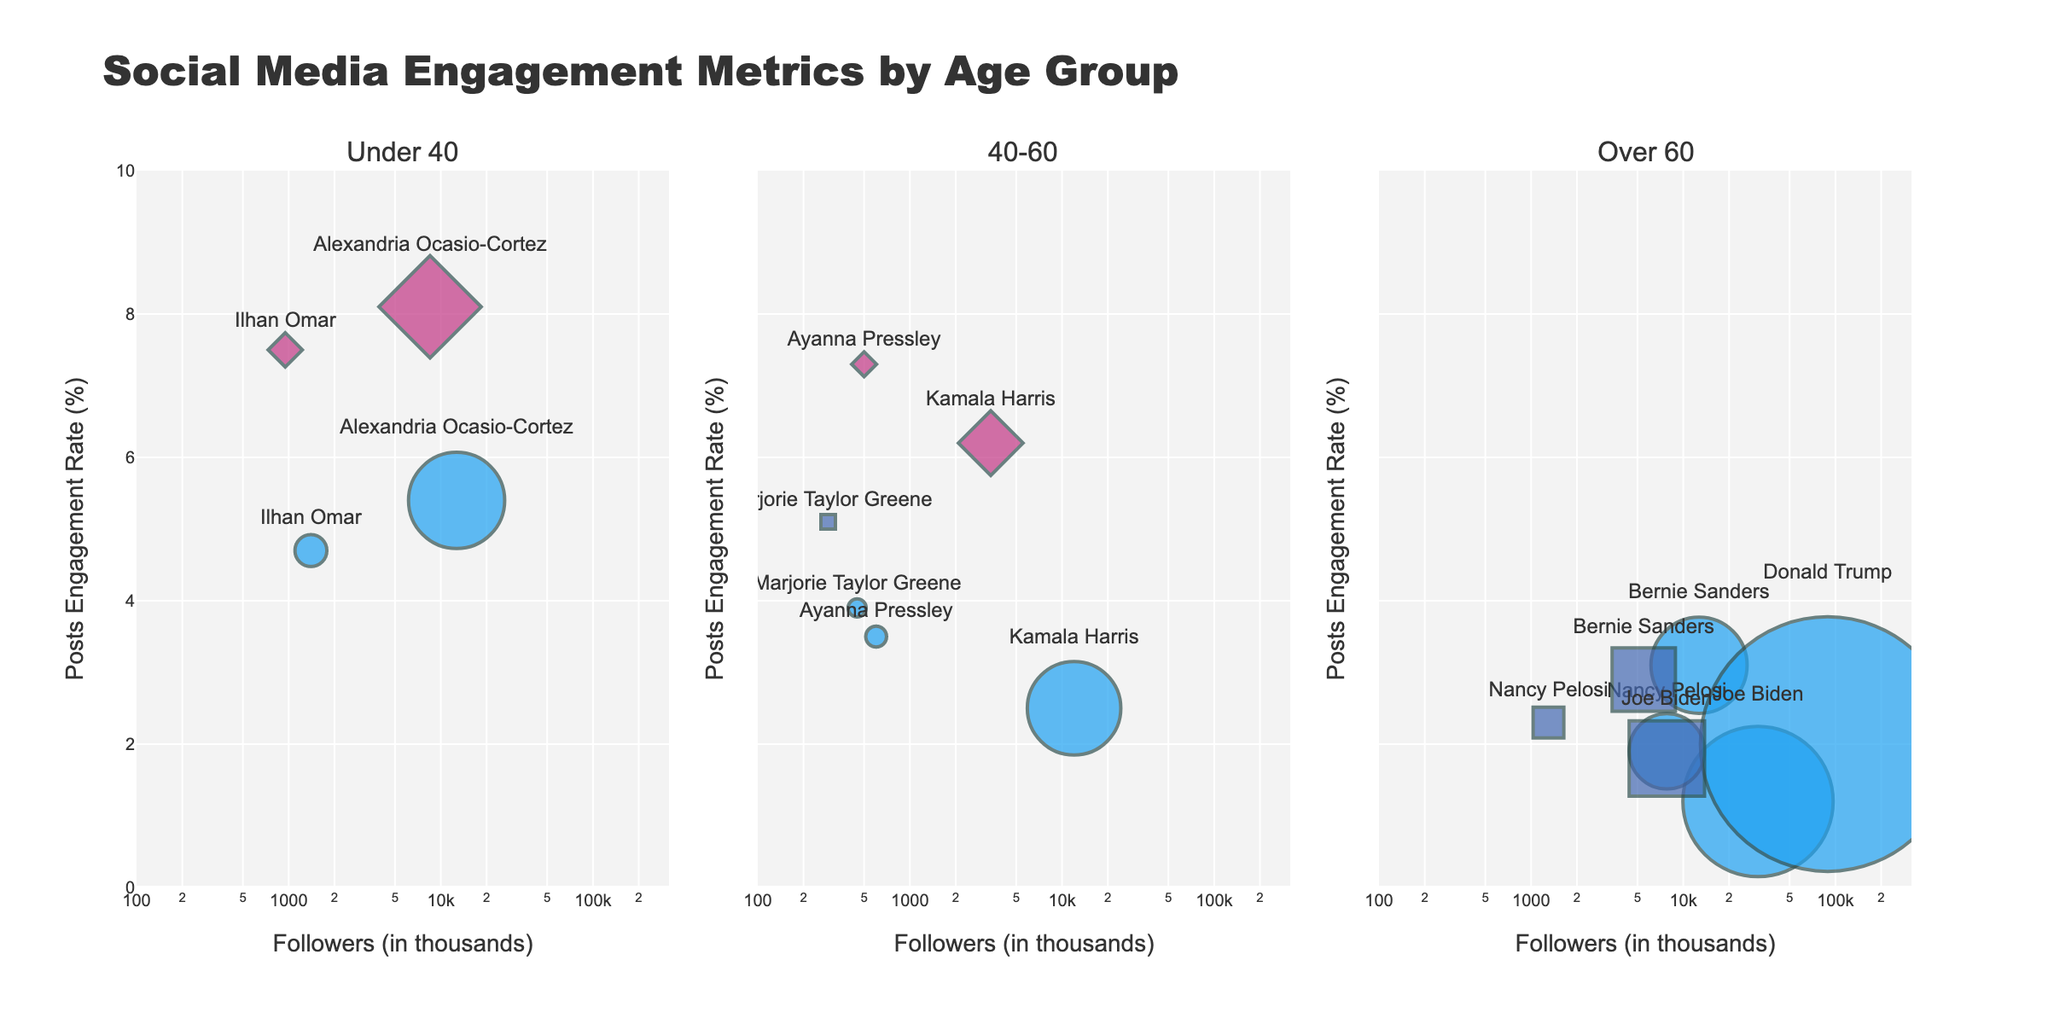What is the title of the figure? The title is displayed at the top of the figure and provides a brief overview of what the figure represents.
Answer: Social Media Engagement Metrics by Age Group How many subplots are there in the figure? The figure is divided into three sections, each representing a different age group.
Answer: Three Which platform does Alexandria Ocasio-Cortez have the highest engagement on? By looking at the markers labeled with Alexandria Ocasio-Cortez's name and comparing their positions on the y-axis, we can see which one is highest. She is highest on Instagram.
Answer: Instagram What is the color used to represent Facebook? The color can be identified from the markers associated with Facebook-labeled data points.
Answer: Blue How many public figures are in the 'Over 60' age group? Count the data points in the third subplot, which represents the 'Over 60' age group.
Answer: Five Who has the highest number of followers among those in the 'Under 40' age group? Check the x-axis for the first subplot and see which data point is farthest to the right. Alexandria Ocasio-Cortez has the highest number of followers in this group.
Answer: Alexandria Ocasio-Cortez What is Kamala Harris's engagement rate on Twitter compared to Instagram? Look at the engagement rates for Kamala Harris in the '40-60' age group subplot on both Twitter and Instagram. Her Twitter engagement rate is 2.5%, while her Instagram engagement rate is 6.2%.
Answer: Kamala Harris's engagement rate is higher on Instagram Which age group generally has higher engagement rates on Instagram? By scanning the y-axis values of the Instagram markers across all three subplots, we can compare the overall engagement rates. The 'Under 40' age group generally has higher engagement rates.
Answer: Under 40 Which public figure has the lowest engagement rate on Twitter in the 'Over 60' age group? Check the y-axis values of the Twitter markers in the 'Over 60' subplot. Joe Biden has the lowest engagement rate on Twitter in this group.
Answer: Joe Biden How does the number of followers for Bernie Sanders compare between Twitter and Facebook? Look at Bernie Sanders' data points in the 'Over 60' age group subplot and compare the x-axis values for Twitter and Facebook. Bernie Sanders has 12,700 followers on Twitter and 5,500 followers on Facebook.
Answer: Bernie Sanders has more followers on Twitter than on Facebook 